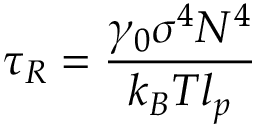<formula> <loc_0><loc_0><loc_500><loc_500>\tau _ { R } = \frac { \gamma _ { 0 } \sigma ^ { 4 } N ^ { 4 } } { k _ { B } T l _ { p } }</formula> 